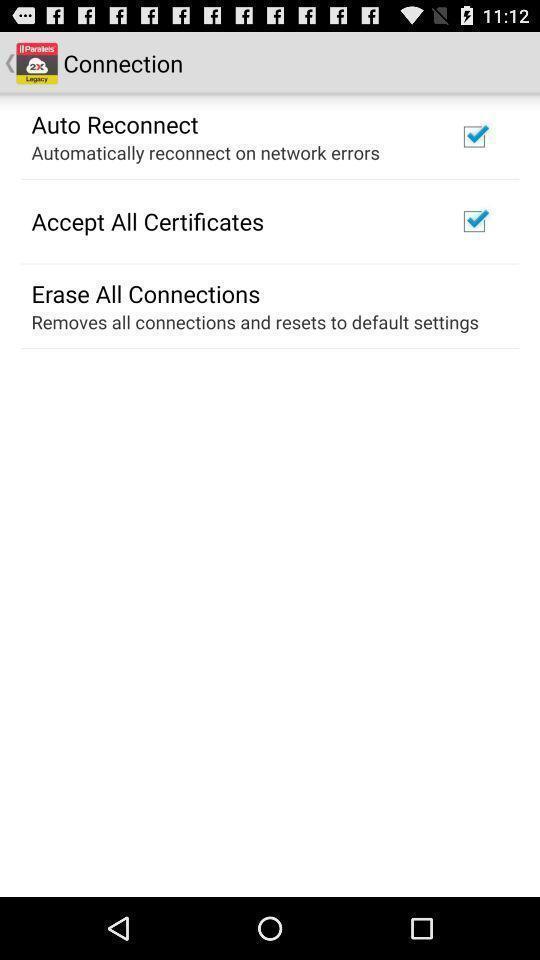Provide a description of this screenshot. Page showing list of options for an app. 